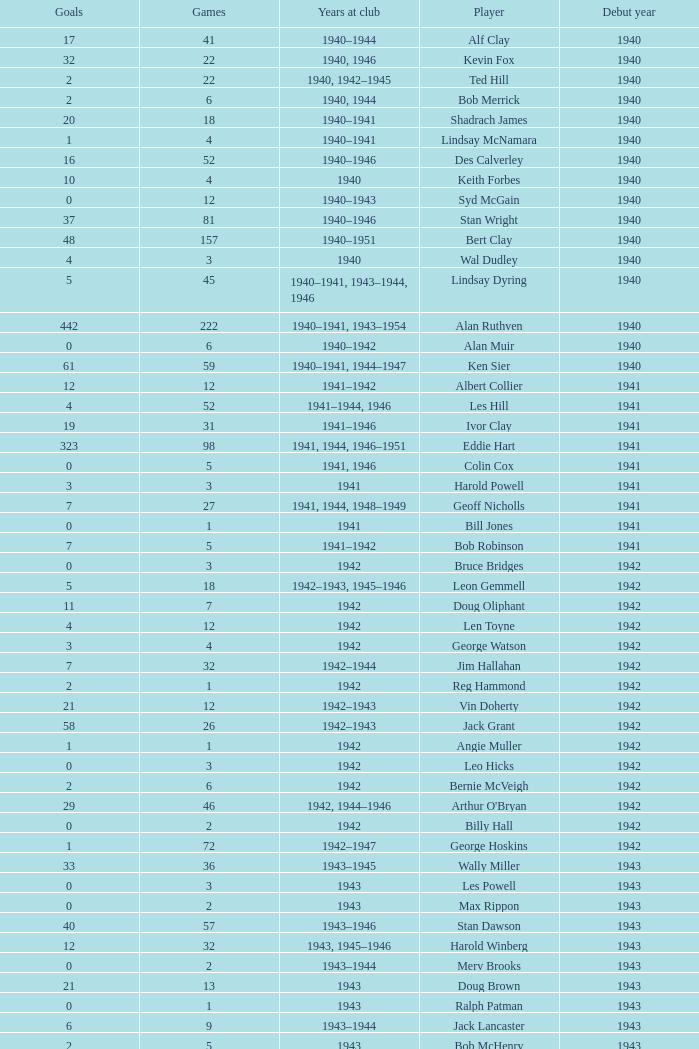Which player debuted before 1943, played for the club in 1942, played less than 12 games, and scored less than 11 goals? Bruce Bridges, George Watson, Reg Hammond, Angie Muller, Leo Hicks, Bernie McVeigh, Billy Hall. 